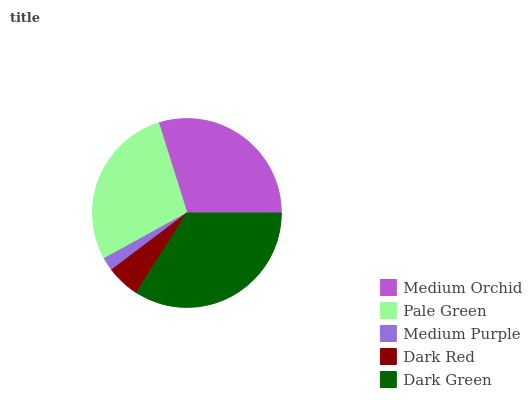Is Medium Purple the minimum?
Answer yes or no. Yes. Is Dark Green the maximum?
Answer yes or no. Yes. Is Pale Green the minimum?
Answer yes or no. No. Is Pale Green the maximum?
Answer yes or no. No. Is Medium Orchid greater than Pale Green?
Answer yes or no. Yes. Is Pale Green less than Medium Orchid?
Answer yes or no. Yes. Is Pale Green greater than Medium Orchid?
Answer yes or no. No. Is Medium Orchid less than Pale Green?
Answer yes or no. No. Is Pale Green the high median?
Answer yes or no. Yes. Is Pale Green the low median?
Answer yes or no. Yes. Is Medium Orchid the high median?
Answer yes or no. No. Is Medium Orchid the low median?
Answer yes or no. No. 